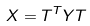<formula> <loc_0><loc_0><loc_500><loc_500>X = T ^ { T } Y T</formula> 